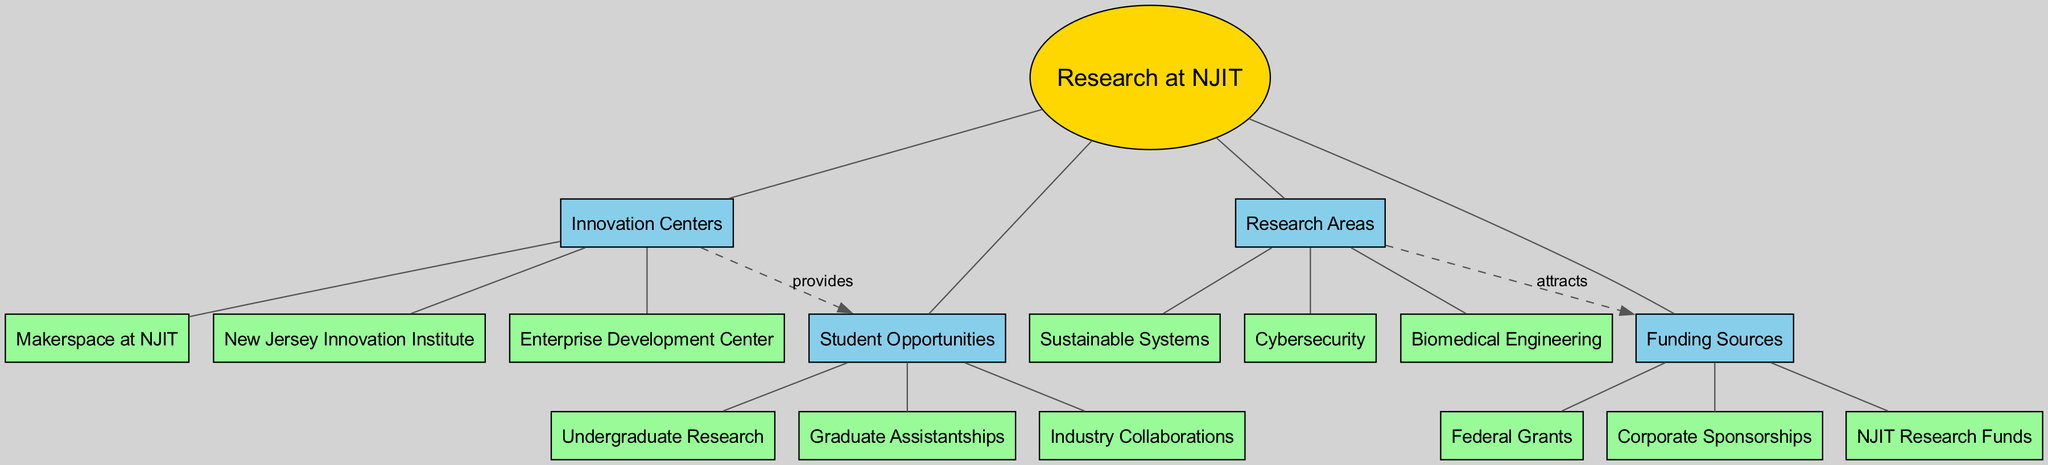What is the central concept of the diagram? The central concept is explicitly labeled at the center of the diagram as "Research at NJIT".
Answer: Research at NJIT How many main branches are there in the diagram? There are four main branches identified in the diagram: Innovation Centers, Research Areas, Student Opportunities, and Funding Sources.
Answer: 4 Which branch provides student opportunities? The branch labeled "Innovation Centers" is indicated to provide student opportunities through its connection to the "Student Opportunities" node.
Answer: Innovation Centers What are three sub-branches under the Research Areas branch? The three sub-branches listed under the Research Areas branch are Cybersecurity, Biomedical Engineering, and Sustainable Systems.
Answer: Cybersecurity, Biomedical Engineering, Sustainable Systems Which funding source is mentioned in relation to attracting research areas? The diagram indicates a connection showing that the "Research Areas" attract "Funding Sources" such as Federal Grants, Corporate Sponsorships, and NJIT Research Funds. Any of these could serve as the answer.
Answer: Federal Grants How many sub-branches does the Student Opportunities branch have? The Student Opportunities branch has three sub-branches: Undergraduate Research, Graduate Assistantships, and Industry Collaborations.
Answer: 3 What type of relationship is shown between Innovation Centers and Student Opportunities? The relationship is labeled "provides", indicating a direct connection where Innovation Centers offer opportunities for students.
Answer: provides Which funding source is specifically mentioned as a type of corporate sponsorship? The diagram includes "Corporate Sponsorships" as a specific category within the Funding Sources branch.
Answer: Corporate Sponsorships Which sub-branch is connected to the Funding Sources branch? The diagram shows that the Research Areas branch is connected to the Funding Sources branch, indicating a flow of attraction.
Answer: Research Areas What color represents the main branches in the diagram? The main branches are represented in a light blue shade, labeled in the diagram as "#87CEEB".
Answer: light blue 